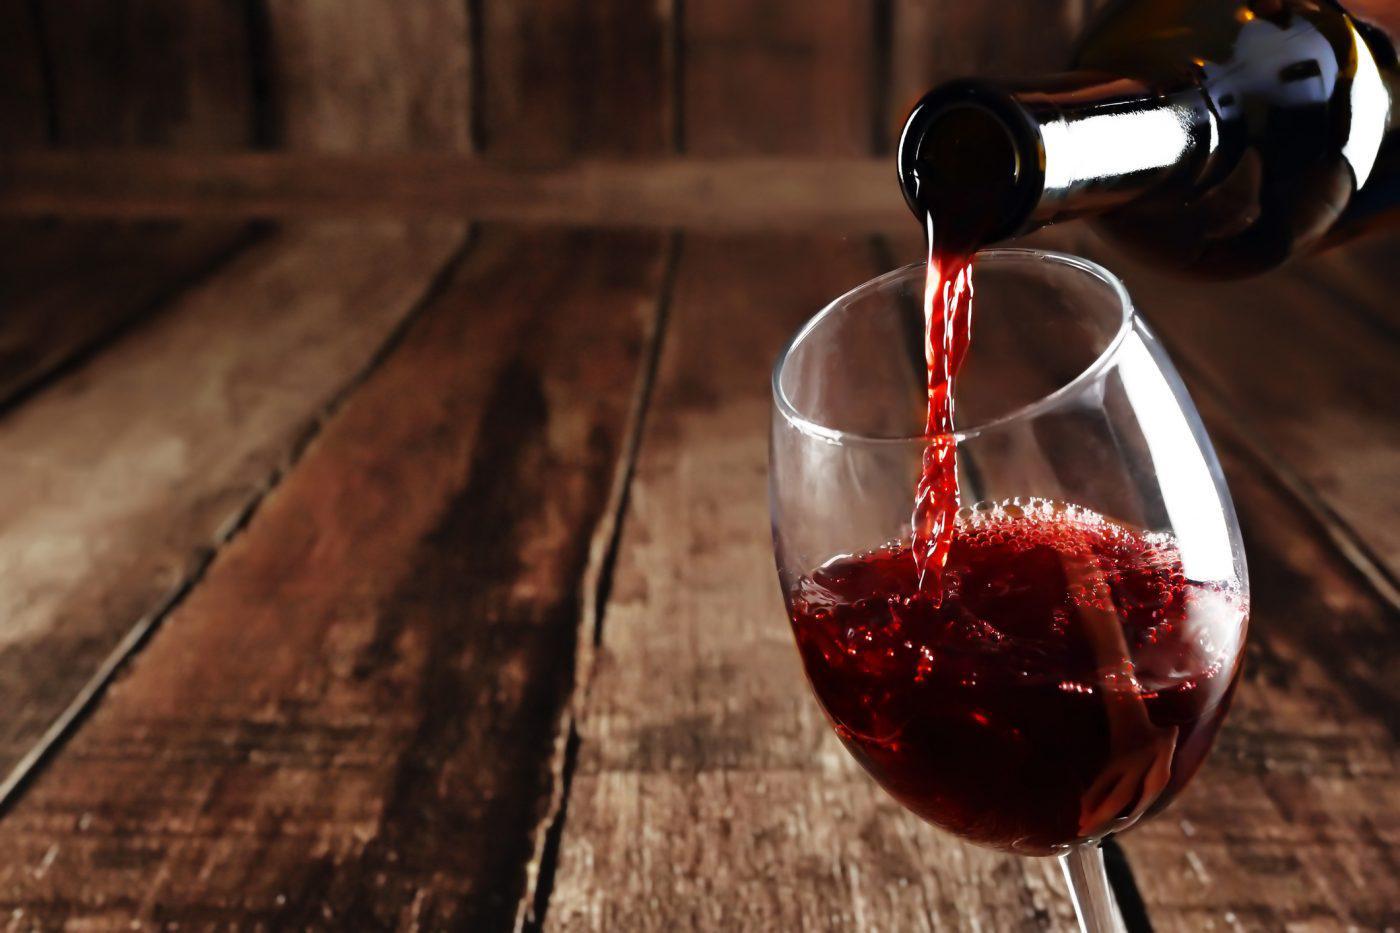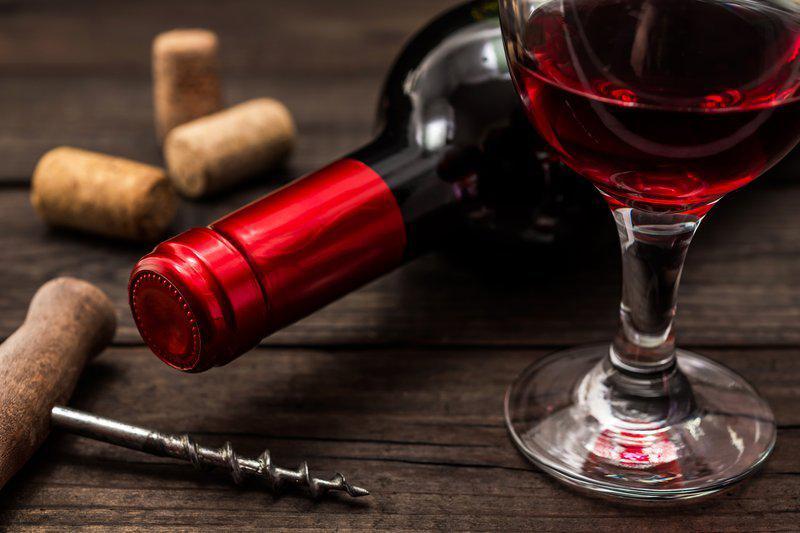The first image is the image on the left, the second image is the image on the right. For the images shown, is this caption "In one of the images, red wine is being poured into a wine glass" true? Answer yes or no. Yes. The first image is the image on the left, the second image is the image on the right. Evaluate the accuracy of this statement regarding the images: "Wine is pouring from a bottle into a glass in the left image.". Is it true? Answer yes or no. Yes. 